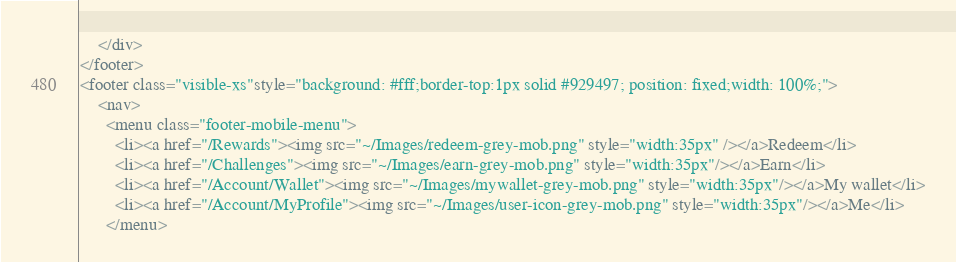<code> <loc_0><loc_0><loc_500><loc_500><_C#_>    </div>
</footer>
<footer class="visible-xs"style="background: #fff;border-top:1px solid #929497; position: fixed;width: 100%;">
    <nav>
      <menu class="footer-mobile-menu">
        <li><a href="/Rewards"><img src="~/Images/redeem-grey-mob.png" style="width:35px" /></a>Redeem</li>
        <li><a href="/Challenges"><img src="~/Images/earn-grey-mob.png" style="width:35px"/></a>Earn</li>
        <li><a href="/Account/Wallet"><img src="~/Images/mywallet-grey-mob.png" style="width:35px"/></a>My wallet</li>
        <li><a href="/Account/MyProfile"><img src="~/Images/user-icon-grey-mob.png" style="width:35px"/></a>Me</li>
      </menu></code> 